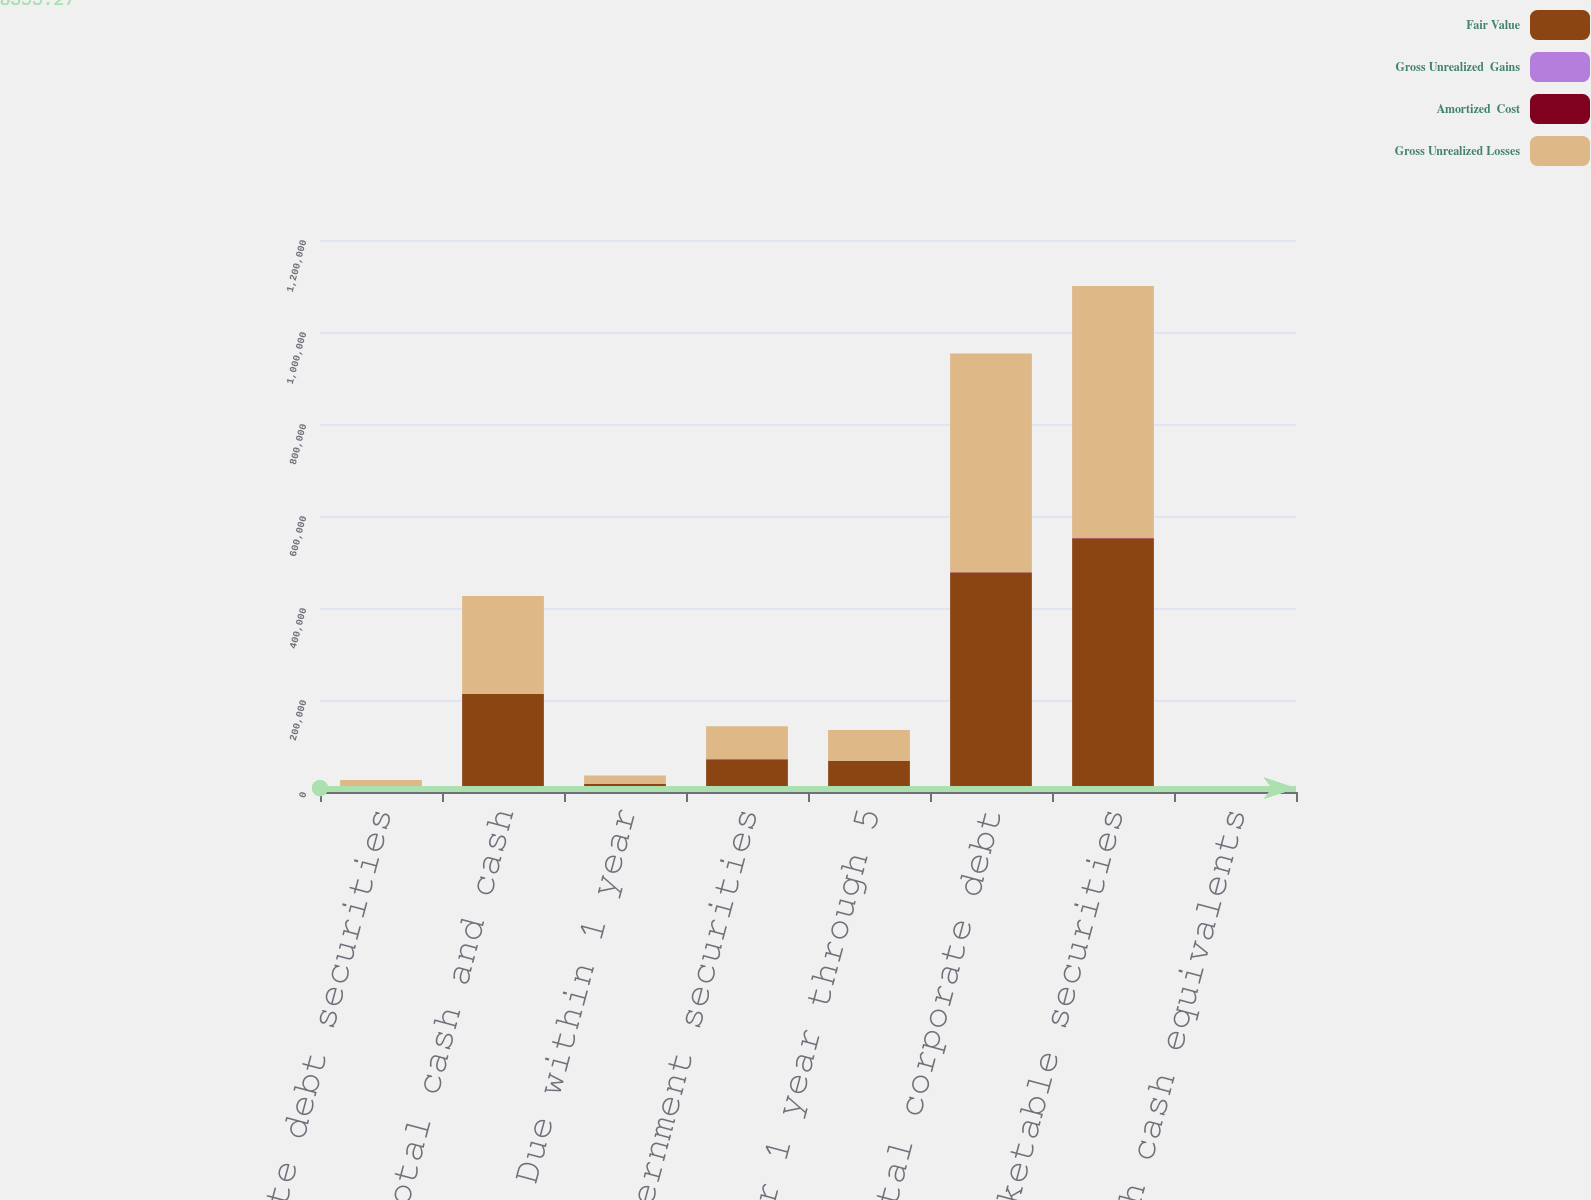Convert chart to OTSL. <chart><loc_0><loc_0><loc_500><loc_500><stacked_bar_chart><ecel><fcel>Corporate debt securities<fcel>Total cash and cash<fcel>Due within 1 year<fcel>Total US government securities<fcel>Due after 1 year through 5<fcel>Total corporate debt<fcel>Total marketable securities<fcel>Total cash cash equivalents<nl><fcel>Fair Value<fcel>13115<fcel>213174<fcel>18026<fcel>71466<fcel>67417<fcel>476461<fcel>549729<fcel>1423<nl><fcel>Gross Unrealized  Gains<fcel>1<fcel>1<fcel>4<fcel>55<fcel>49<fcel>218<fcel>273<fcel>274<nl><fcel>Amortized  Cost<fcel>4<fcel>4<fcel>136<fcel>525<fcel>656<fcel>896<fcel>1421<fcel>1425<nl><fcel>Gross Unrealized Losses<fcel>13112<fcel>213171<fcel>17894<fcel>70996<fcel>66810<fcel>475783<fcel>548581<fcel>1423<nl></chart> 